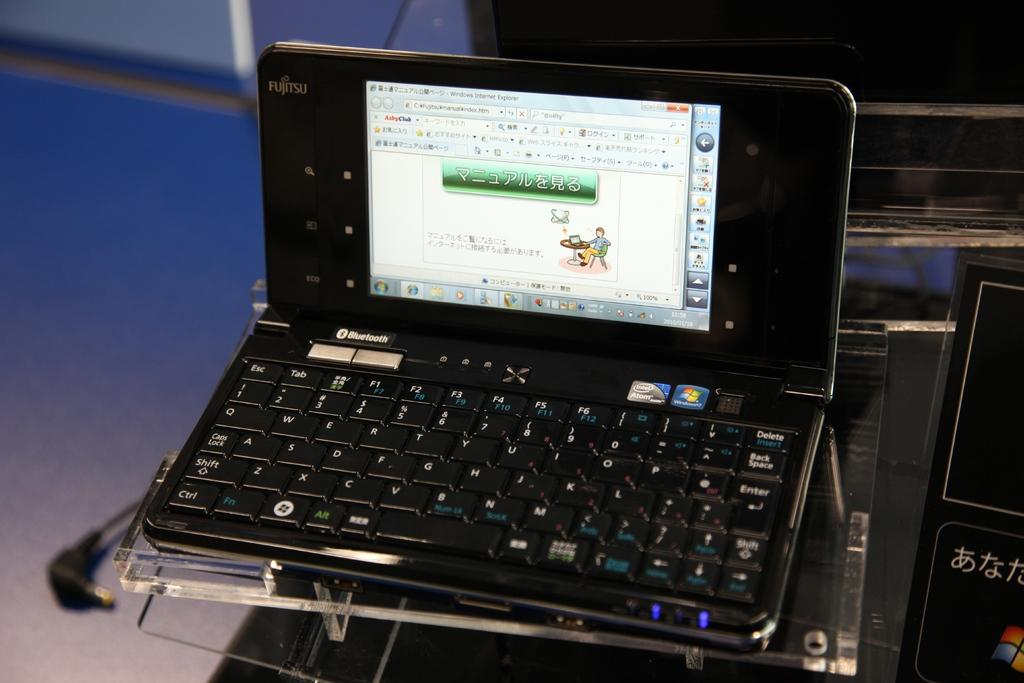<image>
Render a clear and concise summary of the photo. Fujitsu Laptop PC sitting on a desk that is Windows 7 Compatible with Bluetooth. 